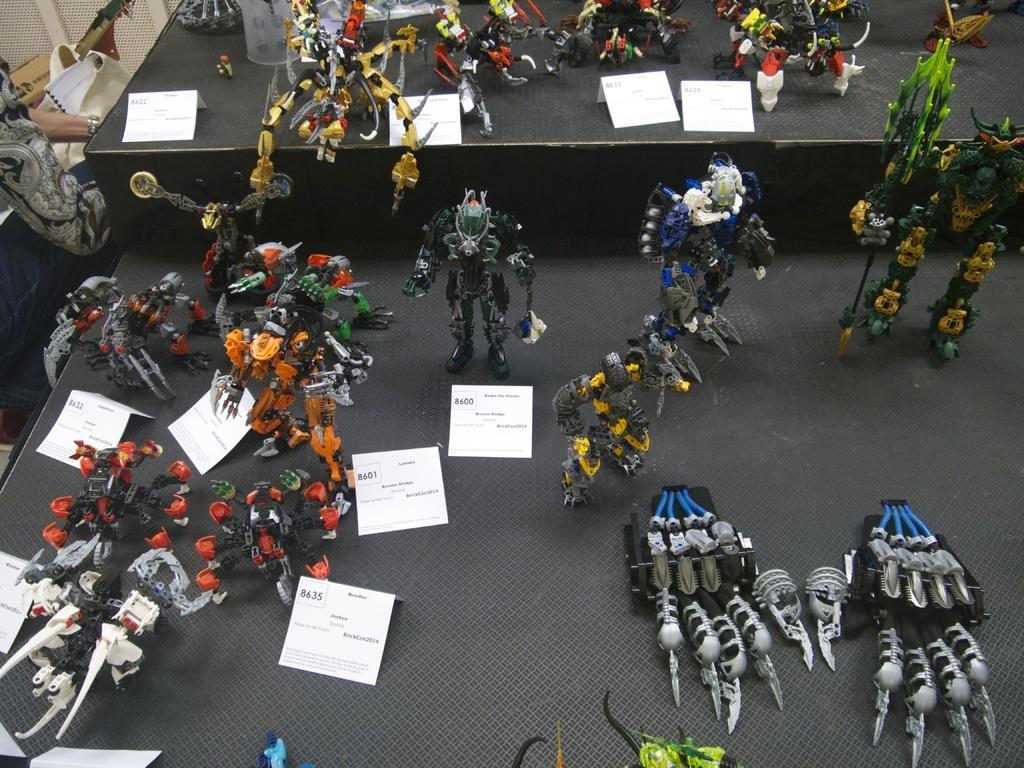In one or two sentences, can you explain what this image depicts? In this picture we can see there are lot of toys and price boards on the objects. On the left side of the toys we can a person hands. 